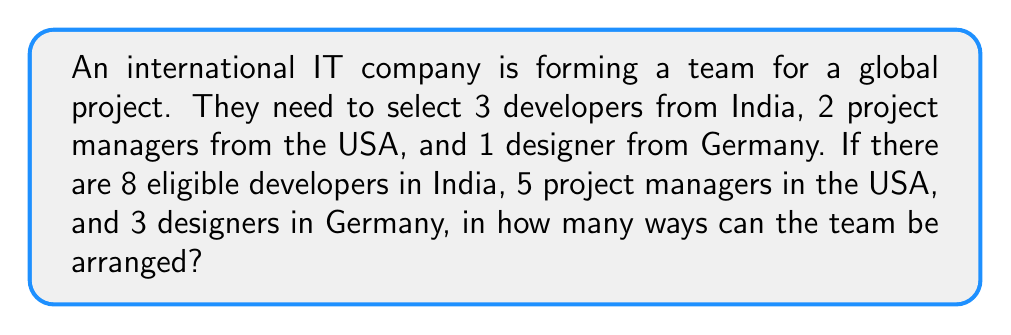Provide a solution to this math problem. Let's break this down step-by-step:

1) First, we need to select the team members:
   - 3 developers from 8 in India: $\binom{8}{3}$
   - 2 project managers from 5 in the USA: $\binom{5}{2}$
   - 1 designer from 3 in Germany: $\binom{3}{1}$

2) The number of ways to select the team is the product of these combinations:

   $$\binom{8}{3} \times \binom{5}{2} \times \binom{3}{1}$$

3) Let's calculate each combination:
   
   $\binom{8}{3} = \frac{8!}{3!(8-3)!} = \frac{8!}{3!5!} = 56$
   
   $\binom{5}{2} = \frac{5!}{2!(5-2)!} = \frac{5!}{2!3!} = 10$
   
   $\binom{3}{1} = \frac{3!}{1!(3-1)!} = \frac{3!}{1!2!} = 3$

4) Multiply these results:

   $56 \times 10 \times 3 = 1680$

5) Now, for each selection, we need to consider the arrangements. With 6 people in total, there are 6! ways to arrange them.

6) The final result is the product of the number of ways to select the team and the number of ways to arrange them:

   $$1680 \times 6! = 1680 \times 720 = 1,209,600$$
Answer: 1,209,600 